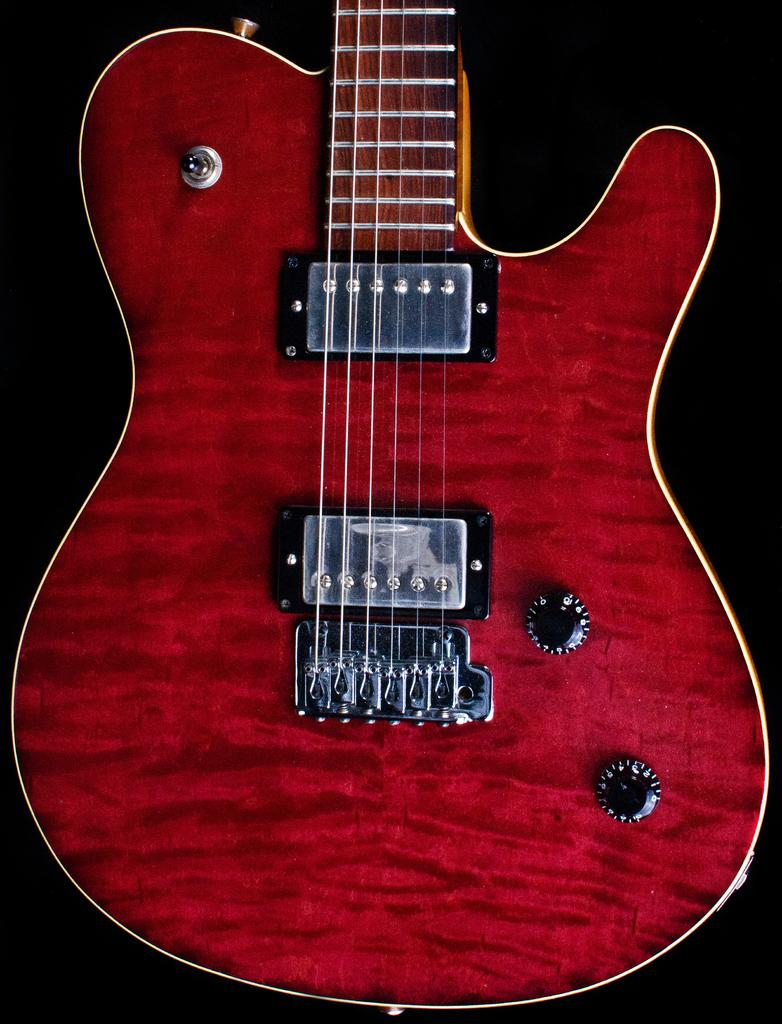What musical instrument is present in the image? There is a guitar in the image. What colors can be seen on the guitar? The guitar is red and black in color. What type of wrench is being used to play the guitar in the image? There is no wrench present in the image, and the guitar is not being played. 